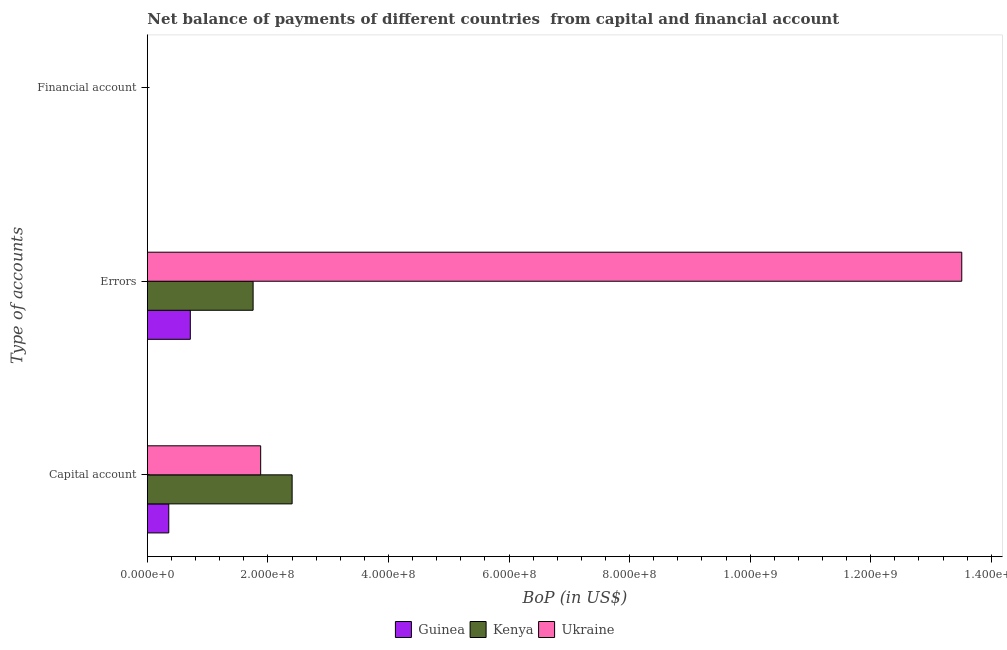How many different coloured bars are there?
Provide a short and direct response. 3. Are the number of bars per tick equal to the number of legend labels?
Ensure brevity in your answer.  No. Are the number of bars on each tick of the Y-axis equal?
Make the answer very short. No. How many bars are there on the 3rd tick from the top?
Keep it short and to the point. 3. How many bars are there on the 3rd tick from the bottom?
Your answer should be compact. 0. What is the label of the 1st group of bars from the top?
Your answer should be compact. Financial account. What is the amount of errors in Guinea?
Offer a terse response. 7.13e+07. Across all countries, what is the maximum amount of errors?
Offer a very short reply. 1.35e+09. Across all countries, what is the minimum amount of financial account?
Ensure brevity in your answer.  0. In which country was the amount of net capital account maximum?
Keep it short and to the point. Kenya. What is the total amount of financial account in the graph?
Keep it short and to the point. 0. What is the difference between the amount of errors in Ukraine and that in Kenya?
Make the answer very short. 1.18e+09. What is the difference between the amount of financial account in Guinea and the amount of errors in Ukraine?
Your response must be concise. -1.35e+09. What is the average amount of errors per country?
Offer a terse response. 5.33e+08. What is the difference between the amount of net capital account and amount of errors in Guinea?
Make the answer very short. -3.57e+07. What is the ratio of the amount of net capital account in Kenya to that in Guinea?
Provide a short and direct response. 6.75. Is the amount of net capital account in Ukraine less than that in Kenya?
Offer a terse response. Yes. What is the difference between the highest and the second highest amount of errors?
Your answer should be very brief. 1.18e+09. What is the difference between the highest and the lowest amount of net capital account?
Provide a short and direct response. 2.05e+08. How many bars are there?
Give a very brief answer. 6. How many countries are there in the graph?
Offer a terse response. 3. What is the difference between two consecutive major ticks on the X-axis?
Keep it short and to the point. 2.00e+08. How many legend labels are there?
Provide a succinct answer. 3. How are the legend labels stacked?
Offer a very short reply. Horizontal. What is the title of the graph?
Keep it short and to the point. Net balance of payments of different countries  from capital and financial account. Does "Serbia" appear as one of the legend labels in the graph?
Provide a short and direct response. No. What is the label or title of the X-axis?
Keep it short and to the point. BoP (in US$). What is the label or title of the Y-axis?
Provide a short and direct response. Type of accounts. What is the BoP (in US$) in Guinea in Capital account?
Your answer should be very brief. 3.56e+07. What is the BoP (in US$) of Kenya in Capital account?
Provide a succinct answer. 2.40e+08. What is the BoP (in US$) in Ukraine in Capital account?
Give a very brief answer. 1.88e+08. What is the BoP (in US$) in Guinea in Errors?
Ensure brevity in your answer.  7.13e+07. What is the BoP (in US$) in Kenya in Errors?
Make the answer very short. 1.75e+08. What is the BoP (in US$) of Ukraine in Errors?
Ensure brevity in your answer.  1.35e+09. What is the BoP (in US$) in Guinea in Financial account?
Provide a short and direct response. 0. What is the BoP (in US$) in Kenya in Financial account?
Keep it short and to the point. 0. Across all Type of accounts, what is the maximum BoP (in US$) of Guinea?
Ensure brevity in your answer.  7.13e+07. Across all Type of accounts, what is the maximum BoP (in US$) of Kenya?
Give a very brief answer. 2.40e+08. Across all Type of accounts, what is the maximum BoP (in US$) in Ukraine?
Make the answer very short. 1.35e+09. Across all Type of accounts, what is the minimum BoP (in US$) in Guinea?
Make the answer very short. 0. Across all Type of accounts, what is the minimum BoP (in US$) of Ukraine?
Provide a succinct answer. 0. What is the total BoP (in US$) in Guinea in the graph?
Keep it short and to the point. 1.07e+08. What is the total BoP (in US$) of Kenya in the graph?
Provide a succinct answer. 4.16e+08. What is the total BoP (in US$) in Ukraine in the graph?
Your answer should be compact. 1.54e+09. What is the difference between the BoP (in US$) of Guinea in Capital account and that in Errors?
Keep it short and to the point. -3.57e+07. What is the difference between the BoP (in US$) of Kenya in Capital account and that in Errors?
Make the answer very short. 6.47e+07. What is the difference between the BoP (in US$) in Ukraine in Capital account and that in Errors?
Offer a very short reply. -1.16e+09. What is the difference between the BoP (in US$) in Guinea in Capital account and the BoP (in US$) in Kenya in Errors?
Ensure brevity in your answer.  -1.40e+08. What is the difference between the BoP (in US$) of Guinea in Capital account and the BoP (in US$) of Ukraine in Errors?
Provide a succinct answer. -1.32e+09. What is the difference between the BoP (in US$) in Kenya in Capital account and the BoP (in US$) in Ukraine in Errors?
Keep it short and to the point. -1.11e+09. What is the average BoP (in US$) of Guinea per Type of accounts?
Give a very brief answer. 3.56e+07. What is the average BoP (in US$) in Kenya per Type of accounts?
Keep it short and to the point. 1.39e+08. What is the average BoP (in US$) of Ukraine per Type of accounts?
Give a very brief answer. 5.13e+08. What is the difference between the BoP (in US$) in Guinea and BoP (in US$) in Kenya in Capital account?
Provide a short and direct response. -2.05e+08. What is the difference between the BoP (in US$) in Guinea and BoP (in US$) in Ukraine in Capital account?
Provide a short and direct response. -1.52e+08. What is the difference between the BoP (in US$) of Kenya and BoP (in US$) of Ukraine in Capital account?
Offer a very short reply. 5.22e+07. What is the difference between the BoP (in US$) in Guinea and BoP (in US$) in Kenya in Errors?
Provide a succinct answer. -1.04e+08. What is the difference between the BoP (in US$) in Guinea and BoP (in US$) in Ukraine in Errors?
Offer a terse response. -1.28e+09. What is the difference between the BoP (in US$) of Kenya and BoP (in US$) of Ukraine in Errors?
Provide a short and direct response. -1.18e+09. What is the ratio of the BoP (in US$) of Guinea in Capital account to that in Errors?
Your response must be concise. 0.5. What is the ratio of the BoP (in US$) of Kenya in Capital account to that in Errors?
Your answer should be compact. 1.37. What is the ratio of the BoP (in US$) of Ukraine in Capital account to that in Errors?
Offer a terse response. 0.14. What is the difference between the highest and the lowest BoP (in US$) in Guinea?
Make the answer very short. 7.13e+07. What is the difference between the highest and the lowest BoP (in US$) in Kenya?
Your answer should be very brief. 2.40e+08. What is the difference between the highest and the lowest BoP (in US$) of Ukraine?
Your response must be concise. 1.35e+09. 